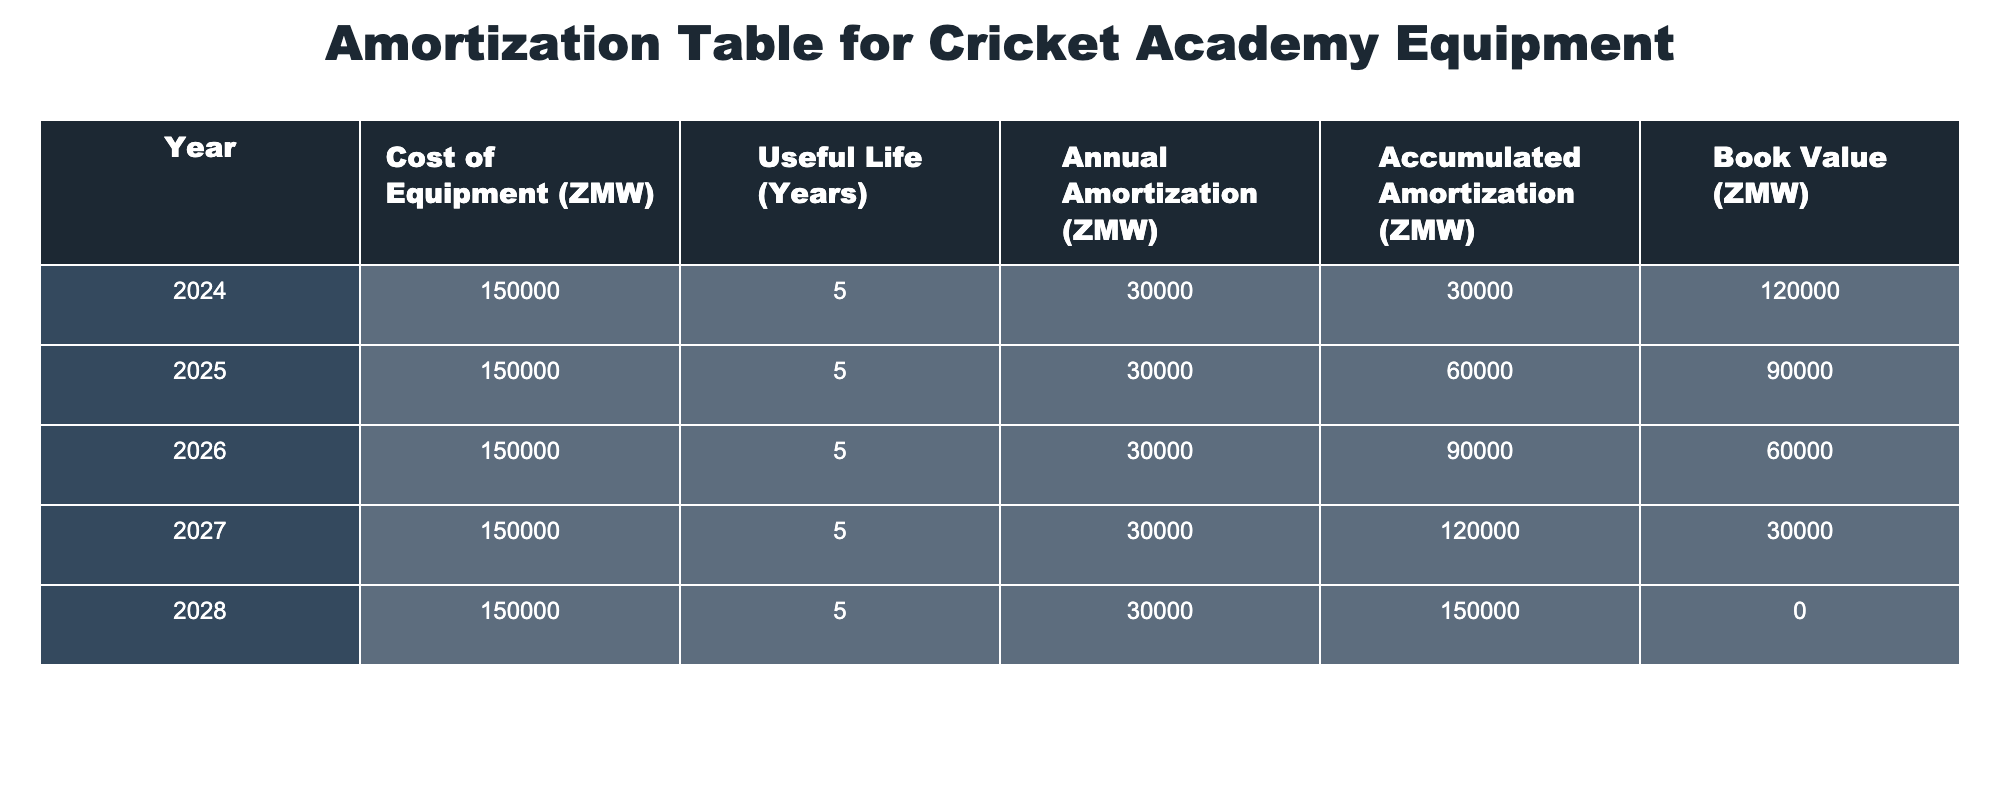What is the total cost of equipment purchased for the cricket academy? The table shows that the cost of equipment is 150,000 ZMW each year for a total of 5 years. Therefore, the total cost is 150,000 ZMW x 5 = 750,000 ZMW.
Answer: 750,000 ZMW What is the book value of the equipment at the end of 2025? According to the table, in 2025, the book value is listed as 90,000 ZMW.
Answer: 90,000 ZMW How much has been accumulated in amortization by the end of 2026? By the end of 2026, the accumulated amortization is 90,000 ZMW according to the table.
Answer: 90,000 ZMW What is the average annual amortization for the equipment over its useful life? The annual amortization is constant at 30,000 ZMW for each year (5 years), so the average is 30,000 ZMW (since they are all the same).
Answer: 30,000 ZMW Is the book value of the equipment zero at the end of the useful life? Yes, at the end of 2028, the book value is listed as zero, indicating that the asset has been fully amortized.
Answer: Yes What is the decrease in book value from 2024 to 2027? From 2024 to 2027, the book value decreases from 120,000 ZMW to 30,000 ZMW. The decrease is 120,000 ZMW - 30,000 ZMW = 90,000 ZMW.
Answer: 90,000 ZMW By how much does the accumulated amortization increase each year? The accumulated amortization increases by 30,000 ZMW each year, as shown in the annual amortization column.
Answer: 30,000 ZMW What was the book value of the equipment after two years of amortization? After two years, in 2025, the book value is 90,000 ZMW according to the table.
Answer: 90,000 ZMW 